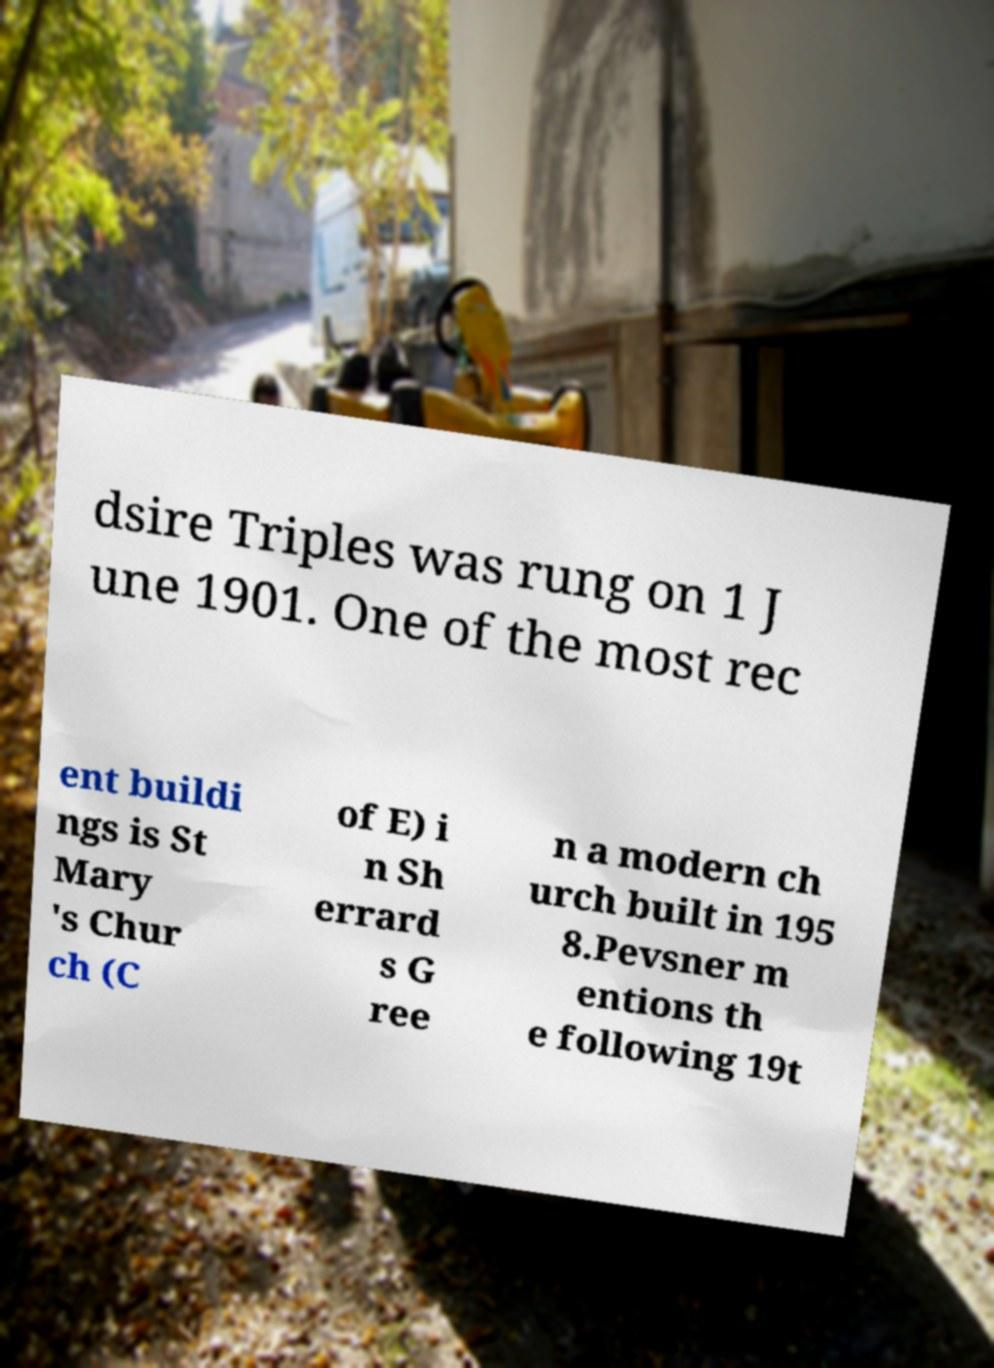There's text embedded in this image that I need extracted. Can you transcribe it verbatim? dsire Triples was rung on 1 J une 1901. One of the most rec ent buildi ngs is St Mary 's Chur ch (C of E) i n Sh errard s G ree n a modern ch urch built in 195 8.Pevsner m entions th e following 19t 